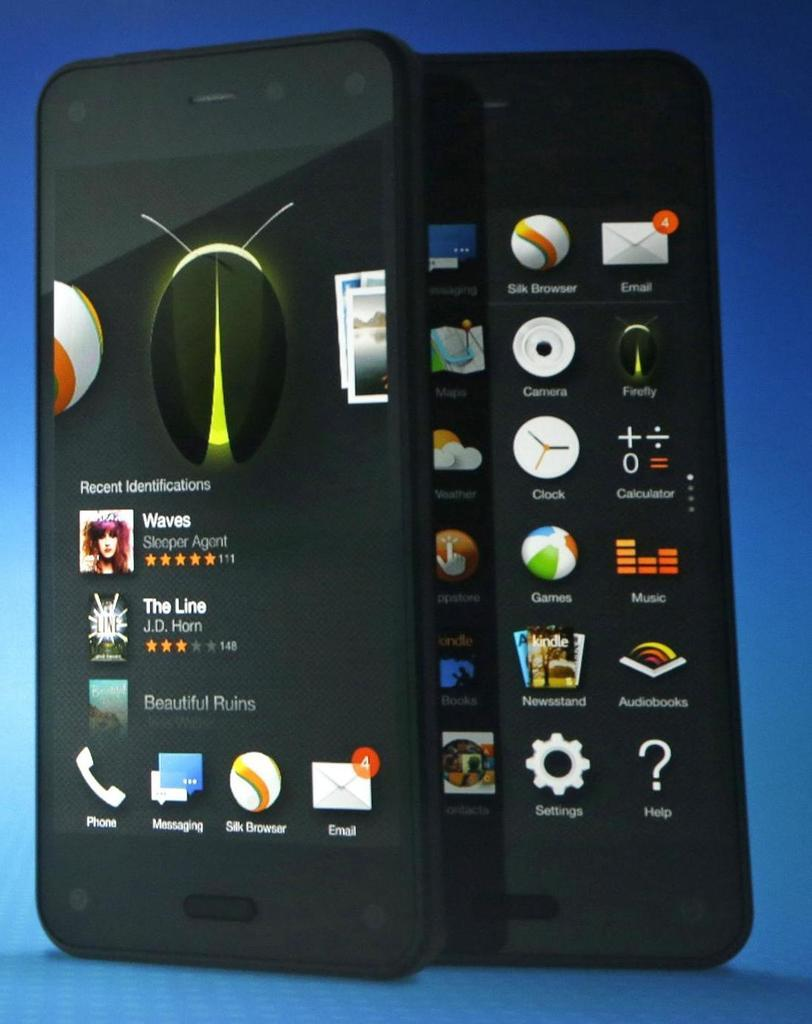Provide a one-sentence caption for the provided image. A cell phone with a listing of Recent Identifications on it. 